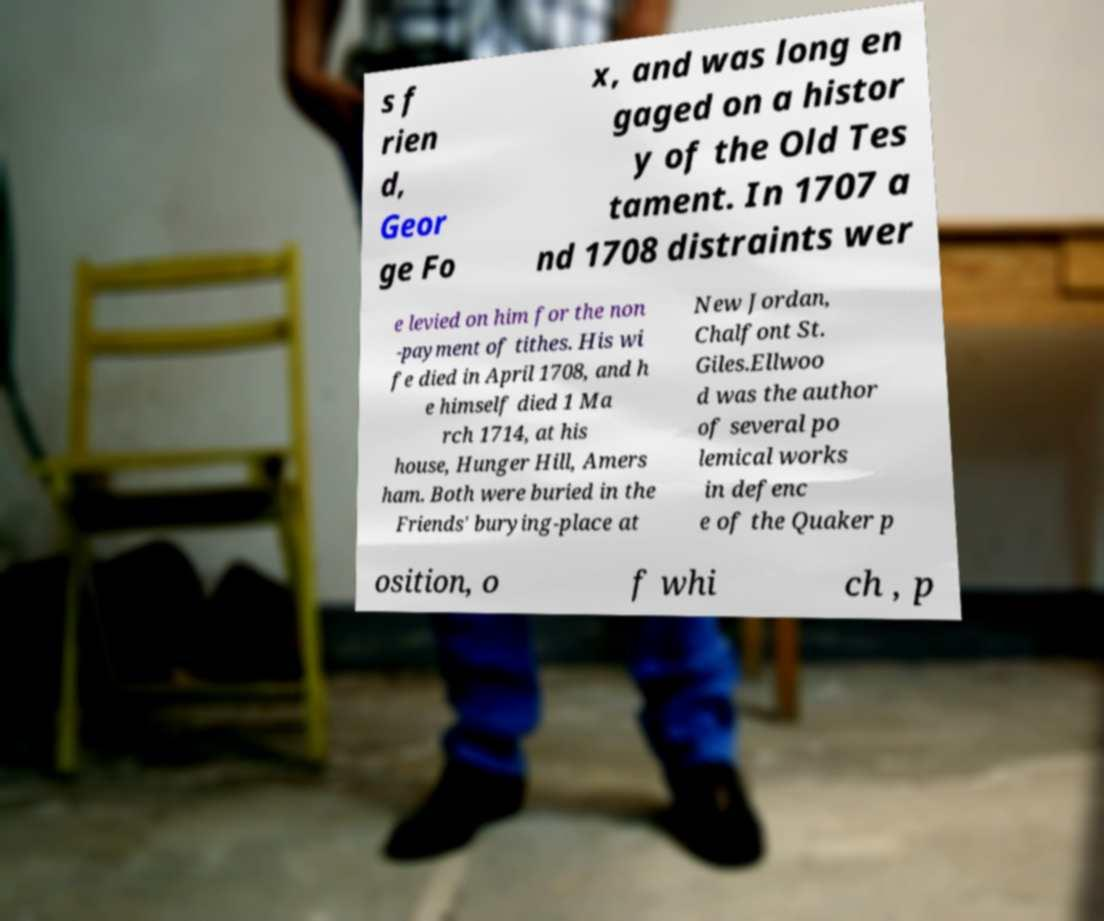Could you assist in decoding the text presented in this image and type it out clearly? s f rien d, Geor ge Fo x, and was long en gaged on a histor y of the Old Tes tament. In 1707 a nd 1708 distraints wer e levied on him for the non -payment of tithes. His wi fe died in April 1708, and h e himself died 1 Ma rch 1714, at his house, Hunger Hill, Amers ham. Both were buried in the Friends' burying-place at New Jordan, Chalfont St. Giles.Ellwoo d was the author of several po lemical works in defenc e of the Quaker p osition, o f whi ch , p 